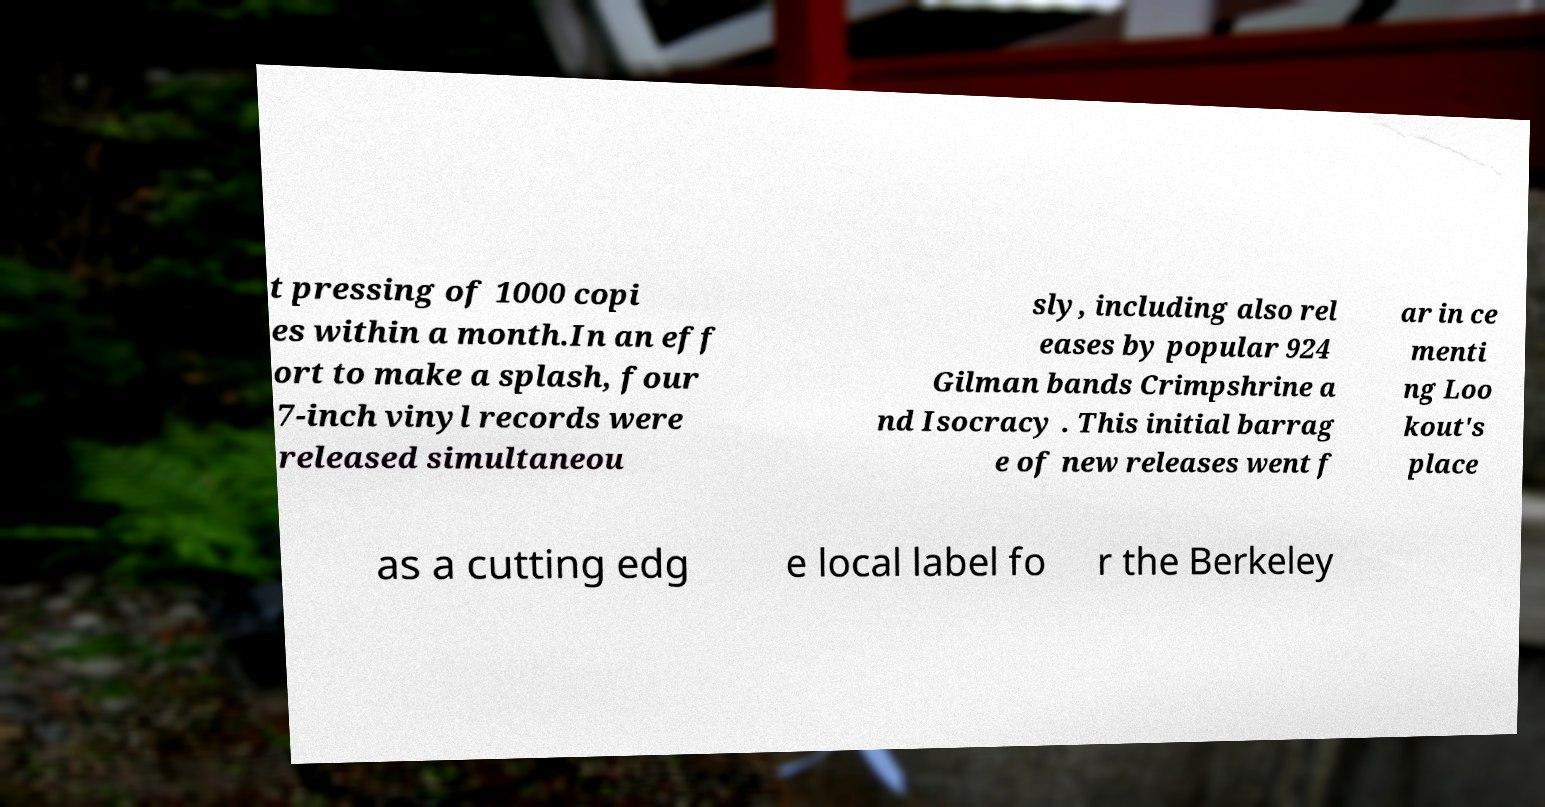Can you read and provide the text displayed in the image?This photo seems to have some interesting text. Can you extract and type it out for me? t pressing of 1000 copi es within a month.In an eff ort to make a splash, four 7-inch vinyl records were released simultaneou sly, including also rel eases by popular 924 Gilman bands Crimpshrine a nd Isocracy . This initial barrag e of new releases went f ar in ce menti ng Loo kout's place as a cutting edg e local label fo r the Berkeley 